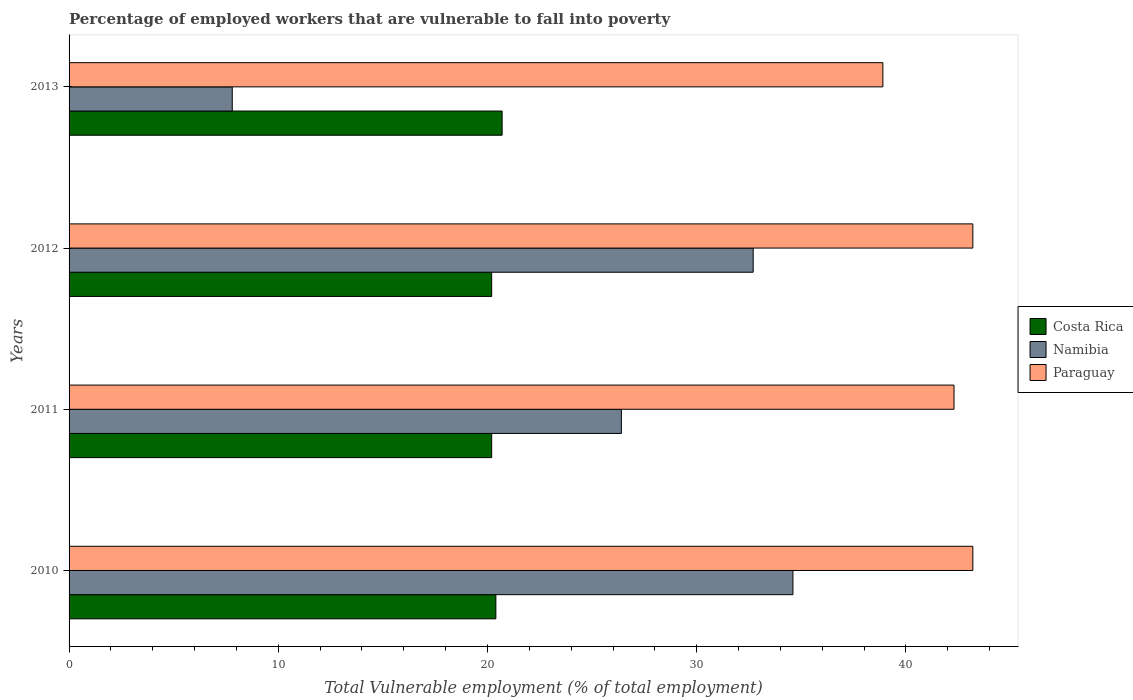How many groups of bars are there?
Offer a terse response. 4. How many bars are there on the 2nd tick from the top?
Ensure brevity in your answer.  3. What is the label of the 3rd group of bars from the top?
Your answer should be compact. 2011. What is the percentage of employed workers who are vulnerable to fall into poverty in Namibia in 2013?
Keep it short and to the point. 7.8. Across all years, what is the maximum percentage of employed workers who are vulnerable to fall into poverty in Namibia?
Offer a very short reply. 34.6. Across all years, what is the minimum percentage of employed workers who are vulnerable to fall into poverty in Paraguay?
Offer a very short reply. 38.9. In which year was the percentage of employed workers who are vulnerable to fall into poverty in Costa Rica maximum?
Offer a very short reply. 2013. In which year was the percentage of employed workers who are vulnerable to fall into poverty in Paraguay minimum?
Provide a succinct answer. 2013. What is the total percentage of employed workers who are vulnerable to fall into poverty in Paraguay in the graph?
Your response must be concise. 167.6. What is the difference between the percentage of employed workers who are vulnerable to fall into poverty in Namibia in 2010 and the percentage of employed workers who are vulnerable to fall into poverty in Paraguay in 2013?
Ensure brevity in your answer.  -4.3. What is the average percentage of employed workers who are vulnerable to fall into poverty in Costa Rica per year?
Offer a terse response. 20.38. In the year 2011, what is the difference between the percentage of employed workers who are vulnerable to fall into poverty in Namibia and percentage of employed workers who are vulnerable to fall into poverty in Paraguay?
Provide a succinct answer. -15.9. What is the ratio of the percentage of employed workers who are vulnerable to fall into poverty in Paraguay in 2012 to that in 2013?
Keep it short and to the point. 1.11. Is the percentage of employed workers who are vulnerable to fall into poverty in Costa Rica in 2010 less than that in 2013?
Offer a terse response. Yes. Is the difference between the percentage of employed workers who are vulnerable to fall into poverty in Namibia in 2010 and 2011 greater than the difference between the percentage of employed workers who are vulnerable to fall into poverty in Paraguay in 2010 and 2011?
Keep it short and to the point. Yes. What is the difference between the highest and the second highest percentage of employed workers who are vulnerable to fall into poverty in Costa Rica?
Provide a short and direct response. 0.3. What is the difference between the highest and the lowest percentage of employed workers who are vulnerable to fall into poverty in Paraguay?
Offer a terse response. 4.3. In how many years, is the percentage of employed workers who are vulnerable to fall into poverty in Namibia greater than the average percentage of employed workers who are vulnerable to fall into poverty in Namibia taken over all years?
Give a very brief answer. 3. Is the sum of the percentage of employed workers who are vulnerable to fall into poverty in Costa Rica in 2010 and 2013 greater than the maximum percentage of employed workers who are vulnerable to fall into poverty in Paraguay across all years?
Make the answer very short. No. What does the 1st bar from the top in 2011 represents?
Give a very brief answer. Paraguay. What does the 1st bar from the bottom in 2012 represents?
Offer a very short reply. Costa Rica. How many years are there in the graph?
Your response must be concise. 4. Does the graph contain any zero values?
Keep it short and to the point. No. Does the graph contain grids?
Your answer should be compact. No. Where does the legend appear in the graph?
Keep it short and to the point. Center right. How many legend labels are there?
Provide a succinct answer. 3. How are the legend labels stacked?
Offer a very short reply. Vertical. What is the title of the graph?
Provide a succinct answer. Percentage of employed workers that are vulnerable to fall into poverty. Does "Argentina" appear as one of the legend labels in the graph?
Give a very brief answer. No. What is the label or title of the X-axis?
Keep it short and to the point. Total Vulnerable employment (% of total employment). What is the label or title of the Y-axis?
Offer a very short reply. Years. What is the Total Vulnerable employment (% of total employment) of Costa Rica in 2010?
Keep it short and to the point. 20.4. What is the Total Vulnerable employment (% of total employment) in Namibia in 2010?
Give a very brief answer. 34.6. What is the Total Vulnerable employment (% of total employment) in Paraguay in 2010?
Your answer should be very brief. 43.2. What is the Total Vulnerable employment (% of total employment) of Costa Rica in 2011?
Offer a very short reply. 20.2. What is the Total Vulnerable employment (% of total employment) in Namibia in 2011?
Your answer should be compact. 26.4. What is the Total Vulnerable employment (% of total employment) in Paraguay in 2011?
Your answer should be compact. 42.3. What is the Total Vulnerable employment (% of total employment) in Costa Rica in 2012?
Give a very brief answer. 20.2. What is the Total Vulnerable employment (% of total employment) in Namibia in 2012?
Provide a short and direct response. 32.7. What is the Total Vulnerable employment (% of total employment) of Paraguay in 2012?
Your answer should be very brief. 43.2. What is the Total Vulnerable employment (% of total employment) in Costa Rica in 2013?
Give a very brief answer. 20.7. What is the Total Vulnerable employment (% of total employment) in Namibia in 2013?
Your answer should be compact. 7.8. What is the Total Vulnerable employment (% of total employment) of Paraguay in 2013?
Give a very brief answer. 38.9. Across all years, what is the maximum Total Vulnerable employment (% of total employment) in Costa Rica?
Provide a short and direct response. 20.7. Across all years, what is the maximum Total Vulnerable employment (% of total employment) of Namibia?
Keep it short and to the point. 34.6. Across all years, what is the maximum Total Vulnerable employment (% of total employment) in Paraguay?
Provide a succinct answer. 43.2. Across all years, what is the minimum Total Vulnerable employment (% of total employment) of Costa Rica?
Your response must be concise. 20.2. Across all years, what is the minimum Total Vulnerable employment (% of total employment) in Namibia?
Your response must be concise. 7.8. Across all years, what is the minimum Total Vulnerable employment (% of total employment) of Paraguay?
Keep it short and to the point. 38.9. What is the total Total Vulnerable employment (% of total employment) in Costa Rica in the graph?
Your response must be concise. 81.5. What is the total Total Vulnerable employment (% of total employment) in Namibia in the graph?
Keep it short and to the point. 101.5. What is the total Total Vulnerable employment (% of total employment) in Paraguay in the graph?
Give a very brief answer. 167.6. What is the difference between the Total Vulnerable employment (% of total employment) of Costa Rica in 2010 and that in 2011?
Your answer should be very brief. 0.2. What is the difference between the Total Vulnerable employment (% of total employment) in Namibia in 2010 and that in 2011?
Your answer should be compact. 8.2. What is the difference between the Total Vulnerable employment (% of total employment) of Namibia in 2010 and that in 2012?
Your answer should be very brief. 1.9. What is the difference between the Total Vulnerable employment (% of total employment) in Paraguay in 2010 and that in 2012?
Keep it short and to the point. 0. What is the difference between the Total Vulnerable employment (% of total employment) of Costa Rica in 2010 and that in 2013?
Offer a very short reply. -0.3. What is the difference between the Total Vulnerable employment (% of total employment) in Namibia in 2010 and that in 2013?
Provide a succinct answer. 26.8. What is the difference between the Total Vulnerable employment (% of total employment) in Costa Rica in 2011 and that in 2012?
Provide a short and direct response. 0. What is the difference between the Total Vulnerable employment (% of total employment) of Namibia in 2011 and that in 2012?
Your answer should be compact. -6.3. What is the difference between the Total Vulnerable employment (% of total employment) of Costa Rica in 2011 and that in 2013?
Your answer should be compact. -0.5. What is the difference between the Total Vulnerable employment (% of total employment) of Namibia in 2011 and that in 2013?
Offer a very short reply. 18.6. What is the difference between the Total Vulnerable employment (% of total employment) in Paraguay in 2011 and that in 2013?
Offer a very short reply. 3.4. What is the difference between the Total Vulnerable employment (% of total employment) in Costa Rica in 2012 and that in 2013?
Keep it short and to the point. -0.5. What is the difference between the Total Vulnerable employment (% of total employment) in Namibia in 2012 and that in 2013?
Offer a very short reply. 24.9. What is the difference between the Total Vulnerable employment (% of total employment) in Costa Rica in 2010 and the Total Vulnerable employment (% of total employment) in Namibia in 2011?
Your answer should be very brief. -6. What is the difference between the Total Vulnerable employment (% of total employment) of Costa Rica in 2010 and the Total Vulnerable employment (% of total employment) of Paraguay in 2011?
Provide a short and direct response. -21.9. What is the difference between the Total Vulnerable employment (% of total employment) of Costa Rica in 2010 and the Total Vulnerable employment (% of total employment) of Paraguay in 2012?
Your answer should be compact. -22.8. What is the difference between the Total Vulnerable employment (% of total employment) in Costa Rica in 2010 and the Total Vulnerable employment (% of total employment) in Namibia in 2013?
Your response must be concise. 12.6. What is the difference between the Total Vulnerable employment (% of total employment) in Costa Rica in 2010 and the Total Vulnerable employment (% of total employment) in Paraguay in 2013?
Your response must be concise. -18.5. What is the difference between the Total Vulnerable employment (% of total employment) in Costa Rica in 2011 and the Total Vulnerable employment (% of total employment) in Namibia in 2012?
Offer a terse response. -12.5. What is the difference between the Total Vulnerable employment (% of total employment) in Namibia in 2011 and the Total Vulnerable employment (% of total employment) in Paraguay in 2012?
Ensure brevity in your answer.  -16.8. What is the difference between the Total Vulnerable employment (% of total employment) in Costa Rica in 2011 and the Total Vulnerable employment (% of total employment) in Namibia in 2013?
Your answer should be compact. 12.4. What is the difference between the Total Vulnerable employment (% of total employment) of Costa Rica in 2011 and the Total Vulnerable employment (% of total employment) of Paraguay in 2013?
Offer a terse response. -18.7. What is the difference between the Total Vulnerable employment (% of total employment) in Namibia in 2011 and the Total Vulnerable employment (% of total employment) in Paraguay in 2013?
Ensure brevity in your answer.  -12.5. What is the difference between the Total Vulnerable employment (% of total employment) of Costa Rica in 2012 and the Total Vulnerable employment (% of total employment) of Namibia in 2013?
Your answer should be very brief. 12.4. What is the difference between the Total Vulnerable employment (% of total employment) in Costa Rica in 2012 and the Total Vulnerable employment (% of total employment) in Paraguay in 2013?
Provide a short and direct response. -18.7. What is the average Total Vulnerable employment (% of total employment) in Costa Rica per year?
Offer a very short reply. 20.38. What is the average Total Vulnerable employment (% of total employment) of Namibia per year?
Your answer should be very brief. 25.38. What is the average Total Vulnerable employment (% of total employment) in Paraguay per year?
Give a very brief answer. 41.9. In the year 2010, what is the difference between the Total Vulnerable employment (% of total employment) of Costa Rica and Total Vulnerable employment (% of total employment) of Namibia?
Give a very brief answer. -14.2. In the year 2010, what is the difference between the Total Vulnerable employment (% of total employment) of Costa Rica and Total Vulnerable employment (% of total employment) of Paraguay?
Offer a terse response. -22.8. In the year 2011, what is the difference between the Total Vulnerable employment (% of total employment) in Costa Rica and Total Vulnerable employment (% of total employment) in Namibia?
Provide a short and direct response. -6.2. In the year 2011, what is the difference between the Total Vulnerable employment (% of total employment) in Costa Rica and Total Vulnerable employment (% of total employment) in Paraguay?
Your response must be concise. -22.1. In the year 2011, what is the difference between the Total Vulnerable employment (% of total employment) of Namibia and Total Vulnerable employment (% of total employment) of Paraguay?
Ensure brevity in your answer.  -15.9. In the year 2013, what is the difference between the Total Vulnerable employment (% of total employment) in Costa Rica and Total Vulnerable employment (% of total employment) in Paraguay?
Your answer should be very brief. -18.2. In the year 2013, what is the difference between the Total Vulnerable employment (% of total employment) of Namibia and Total Vulnerable employment (% of total employment) of Paraguay?
Your response must be concise. -31.1. What is the ratio of the Total Vulnerable employment (% of total employment) of Costa Rica in 2010 to that in 2011?
Make the answer very short. 1.01. What is the ratio of the Total Vulnerable employment (% of total employment) of Namibia in 2010 to that in 2011?
Ensure brevity in your answer.  1.31. What is the ratio of the Total Vulnerable employment (% of total employment) in Paraguay in 2010 to that in 2011?
Make the answer very short. 1.02. What is the ratio of the Total Vulnerable employment (% of total employment) of Costa Rica in 2010 to that in 2012?
Ensure brevity in your answer.  1.01. What is the ratio of the Total Vulnerable employment (% of total employment) in Namibia in 2010 to that in 2012?
Make the answer very short. 1.06. What is the ratio of the Total Vulnerable employment (% of total employment) of Paraguay in 2010 to that in 2012?
Provide a succinct answer. 1. What is the ratio of the Total Vulnerable employment (% of total employment) in Costa Rica in 2010 to that in 2013?
Keep it short and to the point. 0.99. What is the ratio of the Total Vulnerable employment (% of total employment) in Namibia in 2010 to that in 2013?
Your answer should be compact. 4.44. What is the ratio of the Total Vulnerable employment (% of total employment) of Paraguay in 2010 to that in 2013?
Offer a terse response. 1.11. What is the ratio of the Total Vulnerable employment (% of total employment) of Costa Rica in 2011 to that in 2012?
Your answer should be compact. 1. What is the ratio of the Total Vulnerable employment (% of total employment) of Namibia in 2011 to that in 2012?
Provide a short and direct response. 0.81. What is the ratio of the Total Vulnerable employment (% of total employment) in Paraguay in 2011 to that in 2012?
Offer a very short reply. 0.98. What is the ratio of the Total Vulnerable employment (% of total employment) in Costa Rica in 2011 to that in 2013?
Provide a succinct answer. 0.98. What is the ratio of the Total Vulnerable employment (% of total employment) of Namibia in 2011 to that in 2013?
Provide a short and direct response. 3.38. What is the ratio of the Total Vulnerable employment (% of total employment) of Paraguay in 2011 to that in 2013?
Your response must be concise. 1.09. What is the ratio of the Total Vulnerable employment (% of total employment) in Costa Rica in 2012 to that in 2013?
Offer a very short reply. 0.98. What is the ratio of the Total Vulnerable employment (% of total employment) of Namibia in 2012 to that in 2013?
Your response must be concise. 4.19. What is the ratio of the Total Vulnerable employment (% of total employment) in Paraguay in 2012 to that in 2013?
Provide a short and direct response. 1.11. What is the difference between the highest and the second highest Total Vulnerable employment (% of total employment) of Costa Rica?
Offer a very short reply. 0.3. What is the difference between the highest and the second highest Total Vulnerable employment (% of total employment) in Namibia?
Provide a succinct answer. 1.9. What is the difference between the highest and the lowest Total Vulnerable employment (% of total employment) in Namibia?
Offer a very short reply. 26.8. What is the difference between the highest and the lowest Total Vulnerable employment (% of total employment) in Paraguay?
Keep it short and to the point. 4.3. 